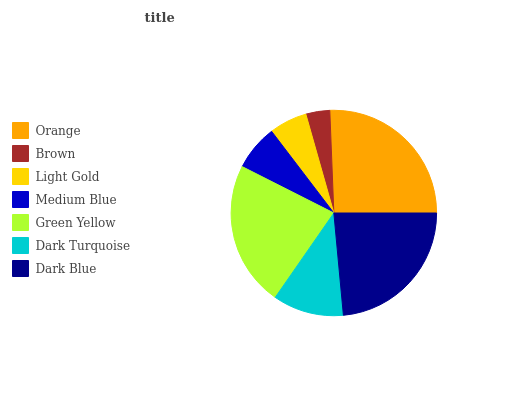Is Brown the minimum?
Answer yes or no. Yes. Is Orange the maximum?
Answer yes or no. Yes. Is Light Gold the minimum?
Answer yes or no. No. Is Light Gold the maximum?
Answer yes or no. No. Is Light Gold greater than Brown?
Answer yes or no. Yes. Is Brown less than Light Gold?
Answer yes or no. Yes. Is Brown greater than Light Gold?
Answer yes or no. No. Is Light Gold less than Brown?
Answer yes or no. No. Is Dark Turquoise the high median?
Answer yes or no. Yes. Is Dark Turquoise the low median?
Answer yes or no. Yes. Is Dark Blue the high median?
Answer yes or no. No. Is Orange the low median?
Answer yes or no. No. 